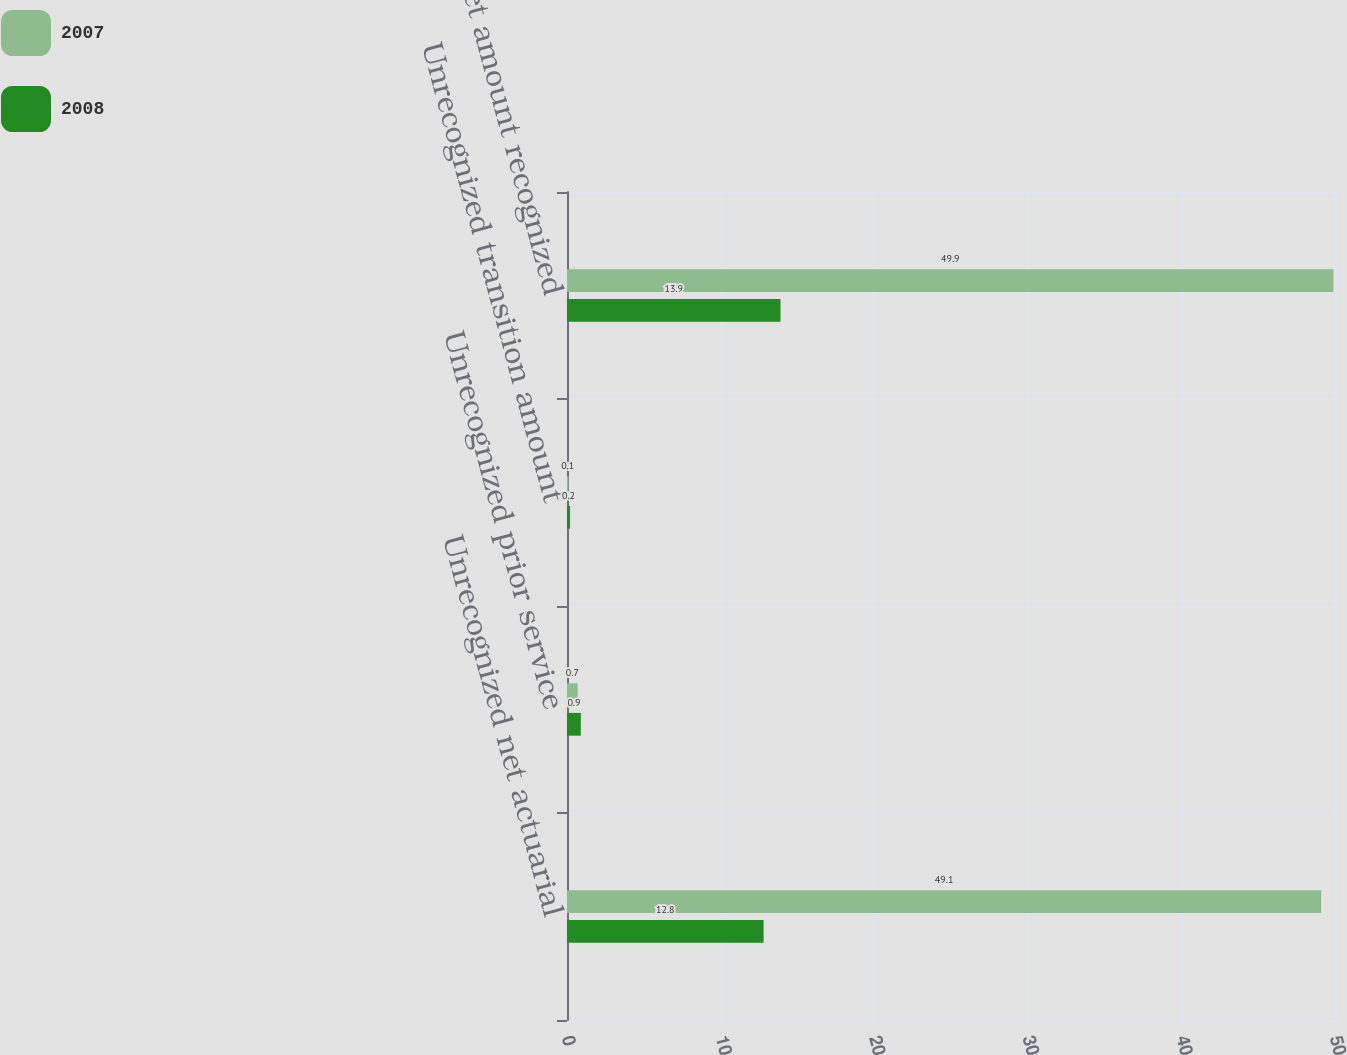Convert chart. <chart><loc_0><loc_0><loc_500><loc_500><stacked_bar_chart><ecel><fcel>Unrecognized net actuarial<fcel>Unrecognized prior service<fcel>Unrecognized transition amount<fcel>Net amount recognized<nl><fcel>2007<fcel>49.1<fcel>0.7<fcel>0.1<fcel>49.9<nl><fcel>2008<fcel>12.8<fcel>0.9<fcel>0.2<fcel>13.9<nl></chart> 